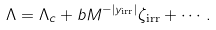Convert formula to latex. <formula><loc_0><loc_0><loc_500><loc_500>\Lambda = \Lambda _ { c } + b M ^ { - | y _ { \text {irr} } | } \zeta _ { \text {irr} } + \cdots .</formula> 